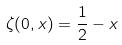Convert formula to latex. <formula><loc_0><loc_0><loc_500><loc_500>\zeta ( 0 , x ) = \frac { 1 } { 2 } - x</formula> 